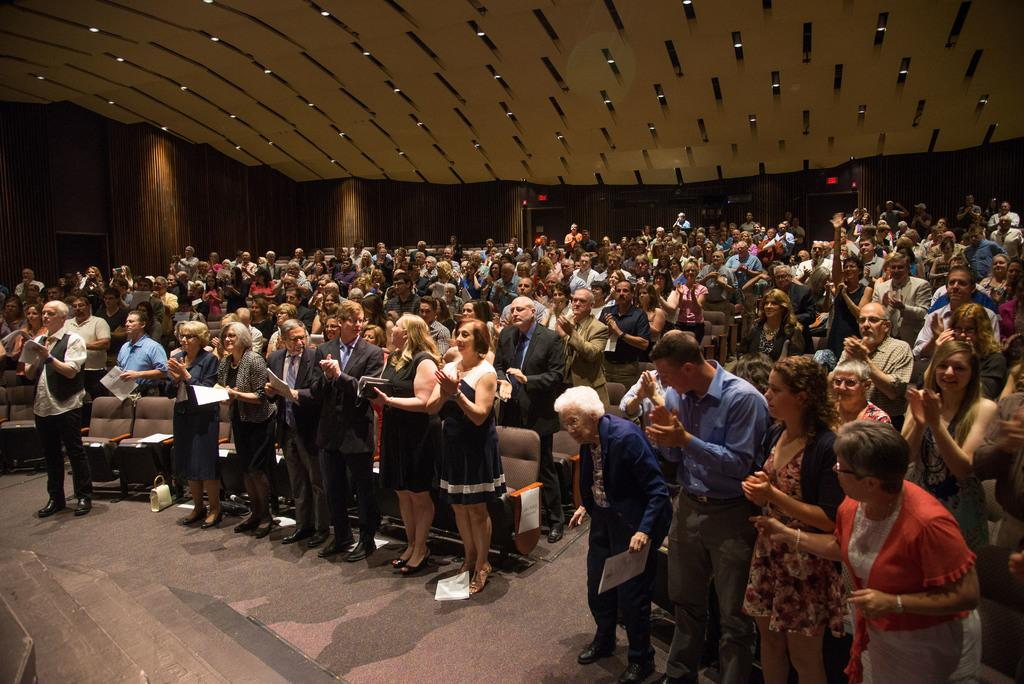What are the people in the image doing? The people in the image are standing and clapping. What might the papers held by some people in the image be related to? The papers held by some people in the image might be related to a presentation or event. What is located in the front of the image? There are chairs in the front of the image. What is visible at the top of the image? There are lights at the top of the image. What type of plantation can be seen in the background of the image? There is no plantation present in the image; it features people standing and clapping, with chairs and lights visible. 